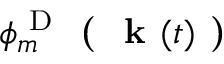Convert formula to latex. <formula><loc_0><loc_0><loc_500><loc_500>\phi _ { m } ^ { D } ( k ( t ) )</formula> 